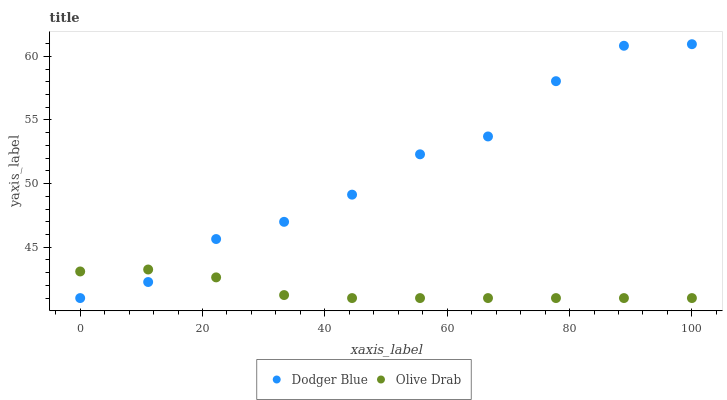Does Olive Drab have the minimum area under the curve?
Answer yes or no. Yes. Does Dodger Blue have the maximum area under the curve?
Answer yes or no. Yes. Does Olive Drab have the maximum area under the curve?
Answer yes or no. No. Is Olive Drab the smoothest?
Answer yes or no. Yes. Is Dodger Blue the roughest?
Answer yes or no. Yes. Is Olive Drab the roughest?
Answer yes or no. No. Does Dodger Blue have the lowest value?
Answer yes or no. Yes. Does Dodger Blue have the highest value?
Answer yes or no. Yes. Does Olive Drab have the highest value?
Answer yes or no. No. Does Olive Drab intersect Dodger Blue?
Answer yes or no. Yes. Is Olive Drab less than Dodger Blue?
Answer yes or no. No. Is Olive Drab greater than Dodger Blue?
Answer yes or no. No. 